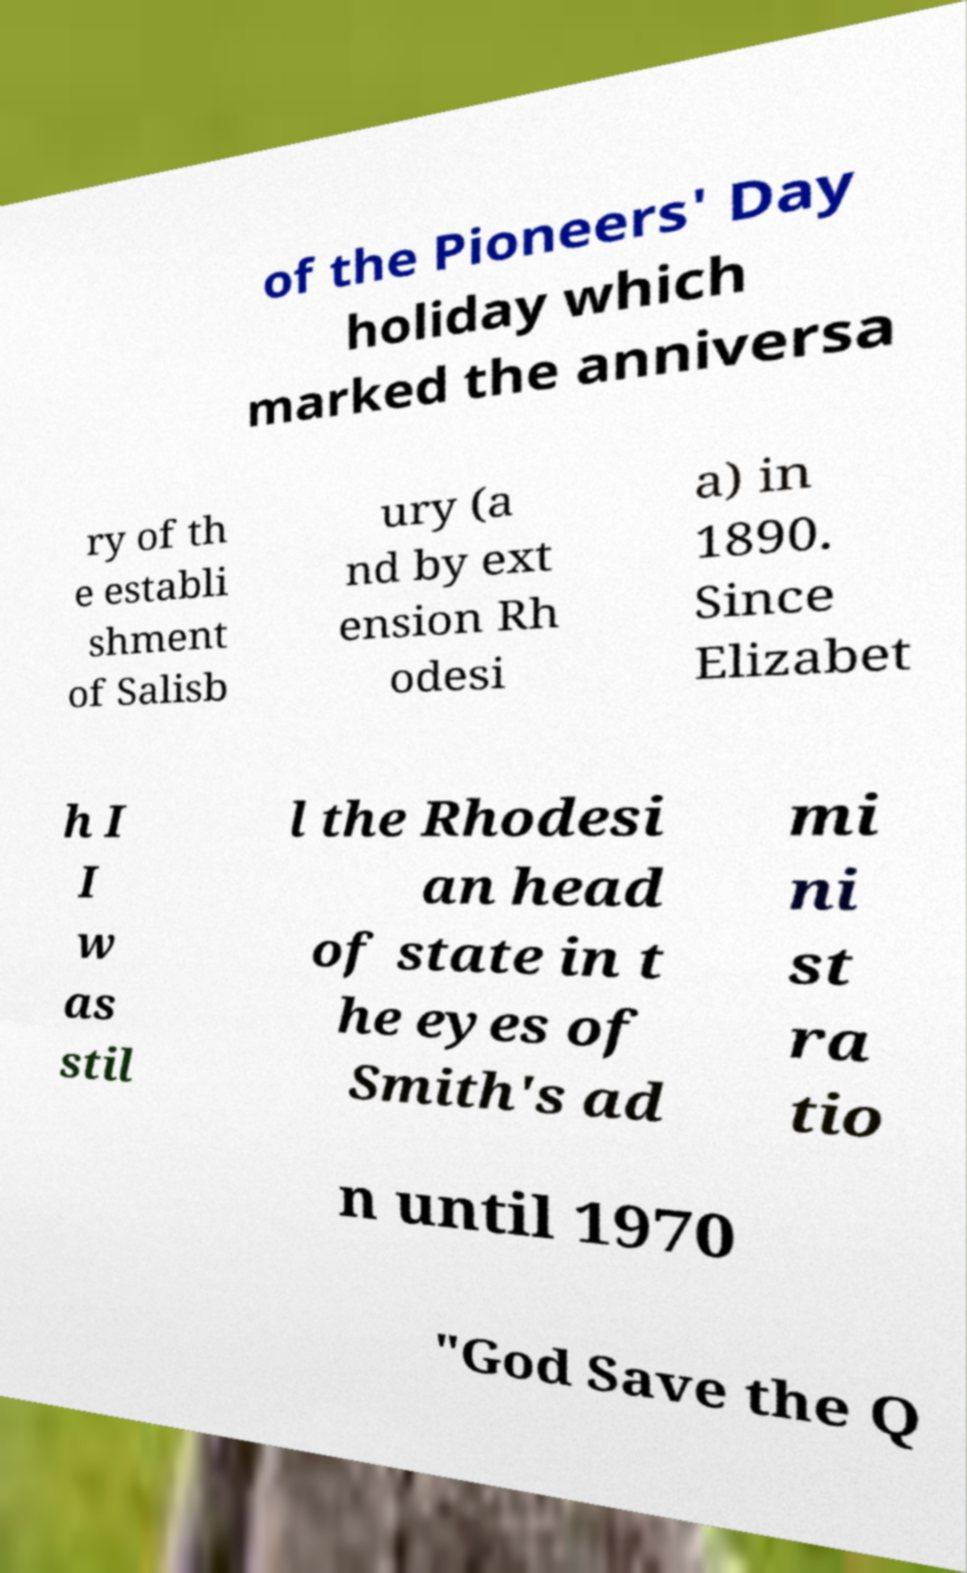Please identify and transcribe the text found in this image. of the Pioneers' Day holiday which marked the anniversa ry of th e establi shment of Salisb ury (a nd by ext ension Rh odesi a) in 1890. Since Elizabet h I I w as stil l the Rhodesi an head of state in t he eyes of Smith's ad mi ni st ra tio n until 1970 "God Save the Q 